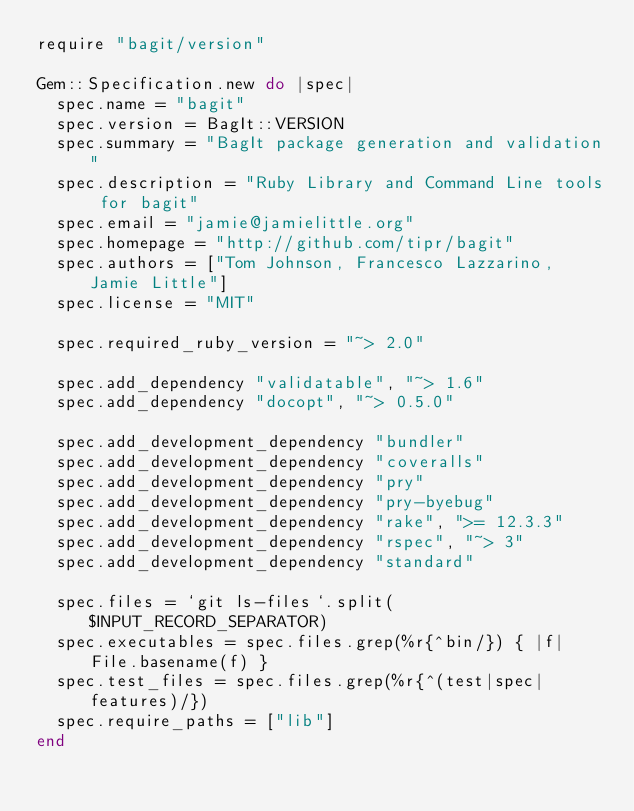Convert code to text. <code><loc_0><loc_0><loc_500><loc_500><_Ruby_>require "bagit/version"

Gem::Specification.new do |spec|
  spec.name = "bagit"
  spec.version = BagIt::VERSION
  spec.summary = "BagIt package generation and validation"
  spec.description = "Ruby Library and Command Line tools for bagit"
  spec.email = "jamie@jamielittle.org"
  spec.homepage = "http://github.com/tipr/bagit"
  spec.authors = ["Tom Johnson, Francesco Lazzarino, Jamie Little"]
  spec.license = "MIT"

  spec.required_ruby_version = "~> 2.0"

  spec.add_dependency "validatable", "~> 1.6"
  spec.add_dependency "docopt", "~> 0.5.0"

  spec.add_development_dependency "bundler"
  spec.add_development_dependency "coveralls"
  spec.add_development_dependency "pry"
  spec.add_development_dependency "pry-byebug"
  spec.add_development_dependency "rake", ">= 12.3.3"
  spec.add_development_dependency "rspec", "~> 3"
  spec.add_development_dependency "standard"

  spec.files = `git ls-files`.split($INPUT_RECORD_SEPARATOR)
  spec.executables = spec.files.grep(%r{^bin/}) { |f| File.basename(f) }
  spec.test_files = spec.files.grep(%r{^(test|spec|features)/})
  spec.require_paths = ["lib"]
end
</code> 